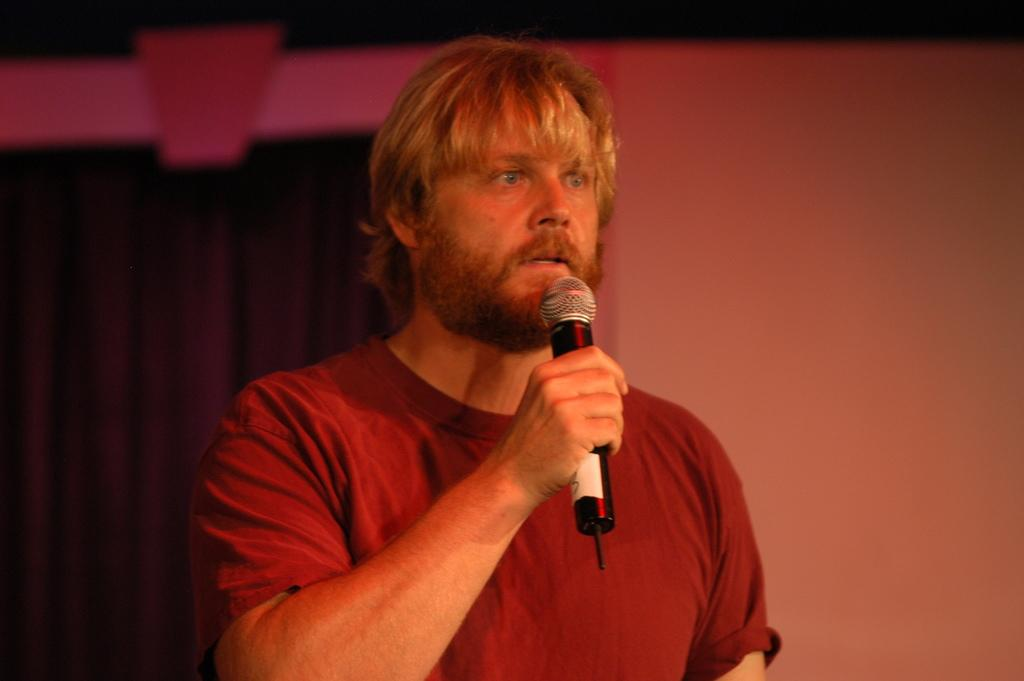Who is present in the image? There is a man in the image. What is the man wearing? The man is wearing a red t-shirt. What is the man holding in the image? The man is holding a mic. What can be seen in the background of the image? There is a blue curtain in the background of the image. How many bees are buzzing around the man in the image? There are no bees present in the image. What is the man's level of wealth based on the image? The image does not provide any information about the man's wealth. 